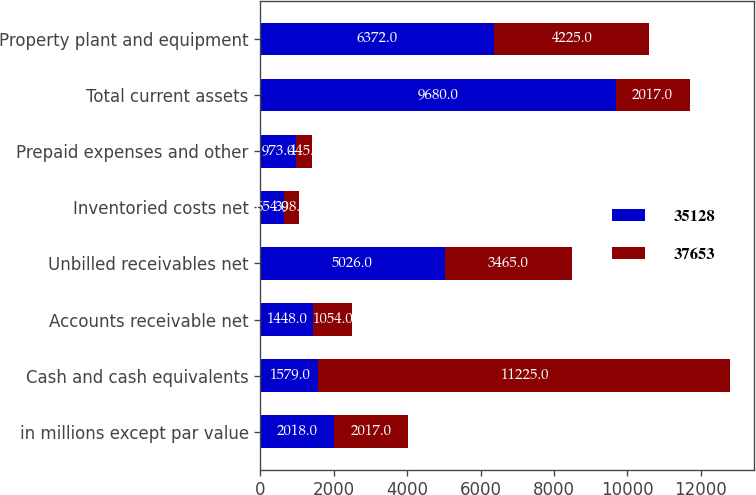<chart> <loc_0><loc_0><loc_500><loc_500><stacked_bar_chart><ecel><fcel>in millions except par value<fcel>Cash and cash equivalents<fcel>Accounts receivable net<fcel>Unbilled receivables net<fcel>Inventoried costs net<fcel>Prepaid expenses and other<fcel>Total current assets<fcel>Property plant and equipment<nl><fcel>35128<fcel>2018<fcel>1579<fcel>1448<fcel>5026<fcel>654<fcel>973<fcel>9680<fcel>6372<nl><fcel>37653<fcel>2017<fcel>11225<fcel>1054<fcel>3465<fcel>398<fcel>445<fcel>2017<fcel>4225<nl></chart> 